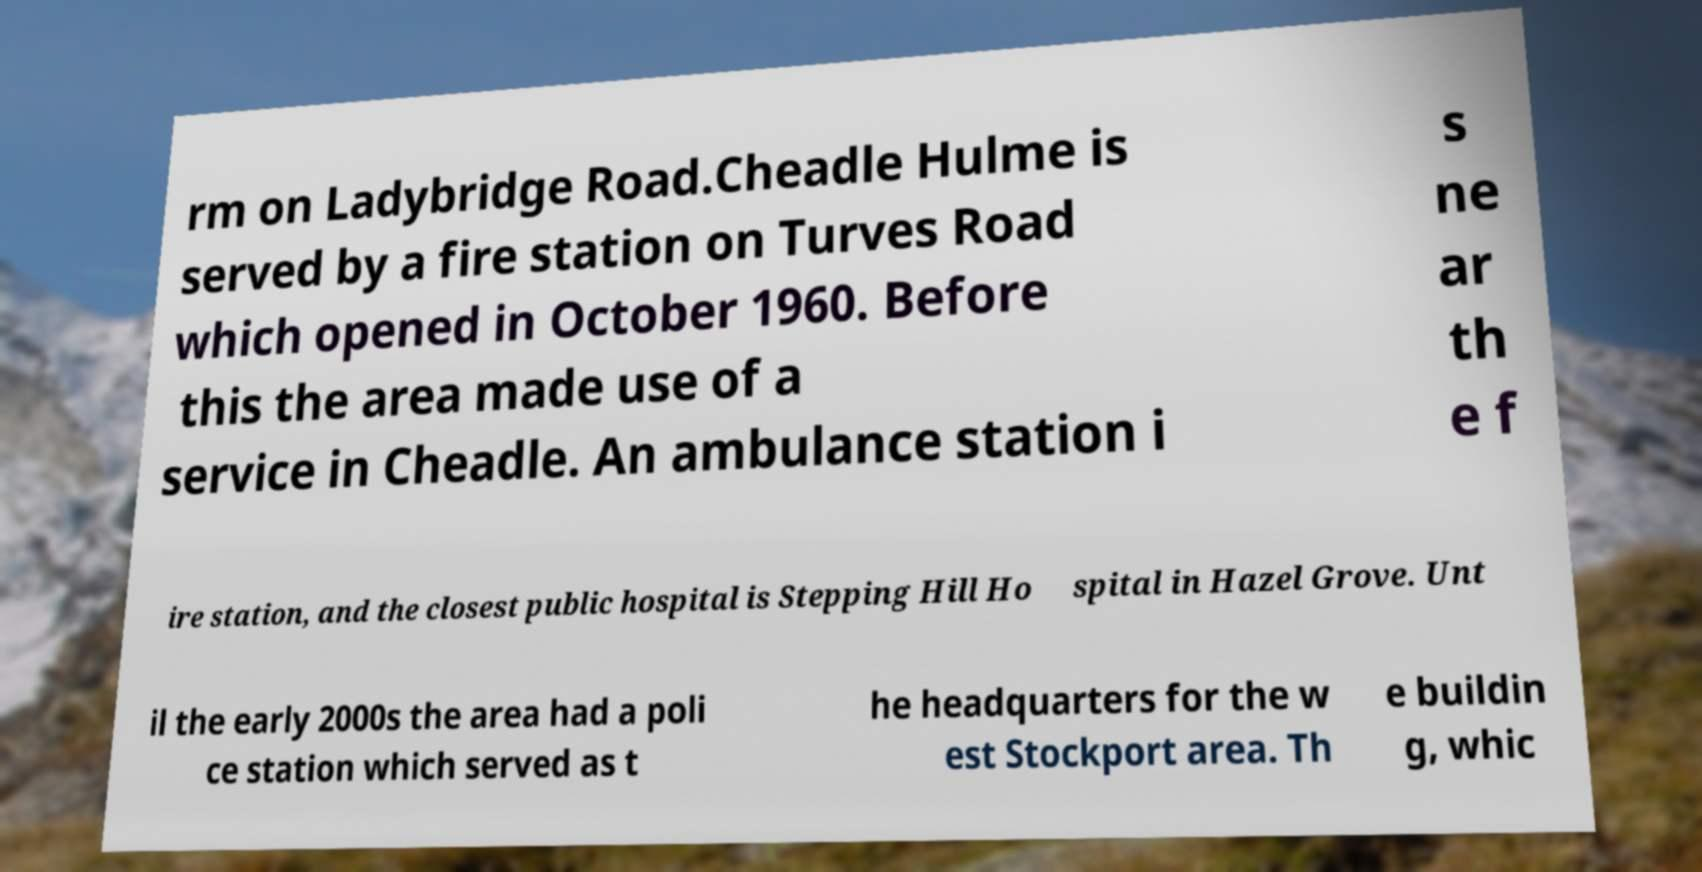There's text embedded in this image that I need extracted. Can you transcribe it verbatim? rm on Ladybridge Road.Cheadle Hulme is served by a fire station on Turves Road which opened in October 1960. Before this the area made use of a service in Cheadle. An ambulance station i s ne ar th e f ire station, and the closest public hospital is Stepping Hill Ho spital in Hazel Grove. Unt il the early 2000s the area had a poli ce station which served as t he headquarters for the w est Stockport area. Th e buildin g, whic 